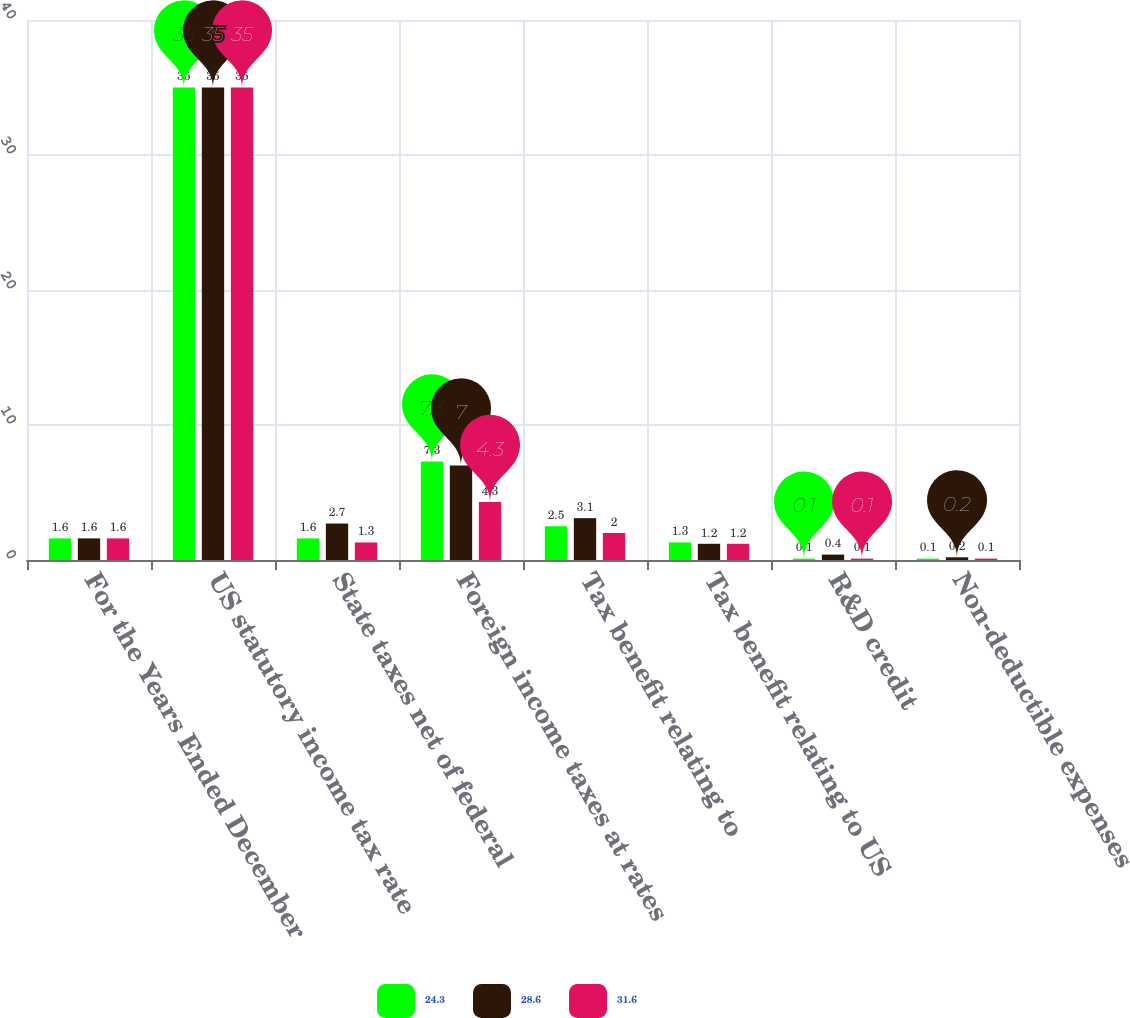Convert chart. <chart><loc_0><loc_0><loc_500><loc_500><stacked_bar_chart><ecel><fcel>For the Years Ended December<fcel>US statutory income tax rate<fcel>State taxes net of federal<fcel>Foreign income taxes at rates<fcel>Tax benefit relating to<fcel>Tax benefit relating to US<fcel>R&D credit<fcel>Non-deductible expenses<nl><fcel>24.3<fcel>1.6<fcel>35<fcel>1.6<fcel>7.3<fcel>2.5<fcel>1.3<fcel>0.1<fcel>0.1<nl><fcel>28.6<fcel>1.6<fcel>35<fcel>2.7<fcel>7<fcel>3.1<fcel>1.2<fcel>0.4<fcel>0.2<nl><fcel>31.6<fcel>1.6<fcel>35<fcel>1.3<fcel>4.3<fcel>2<fcel>1.2<fcel>0.1<fcel>0.1<nl></chart> 